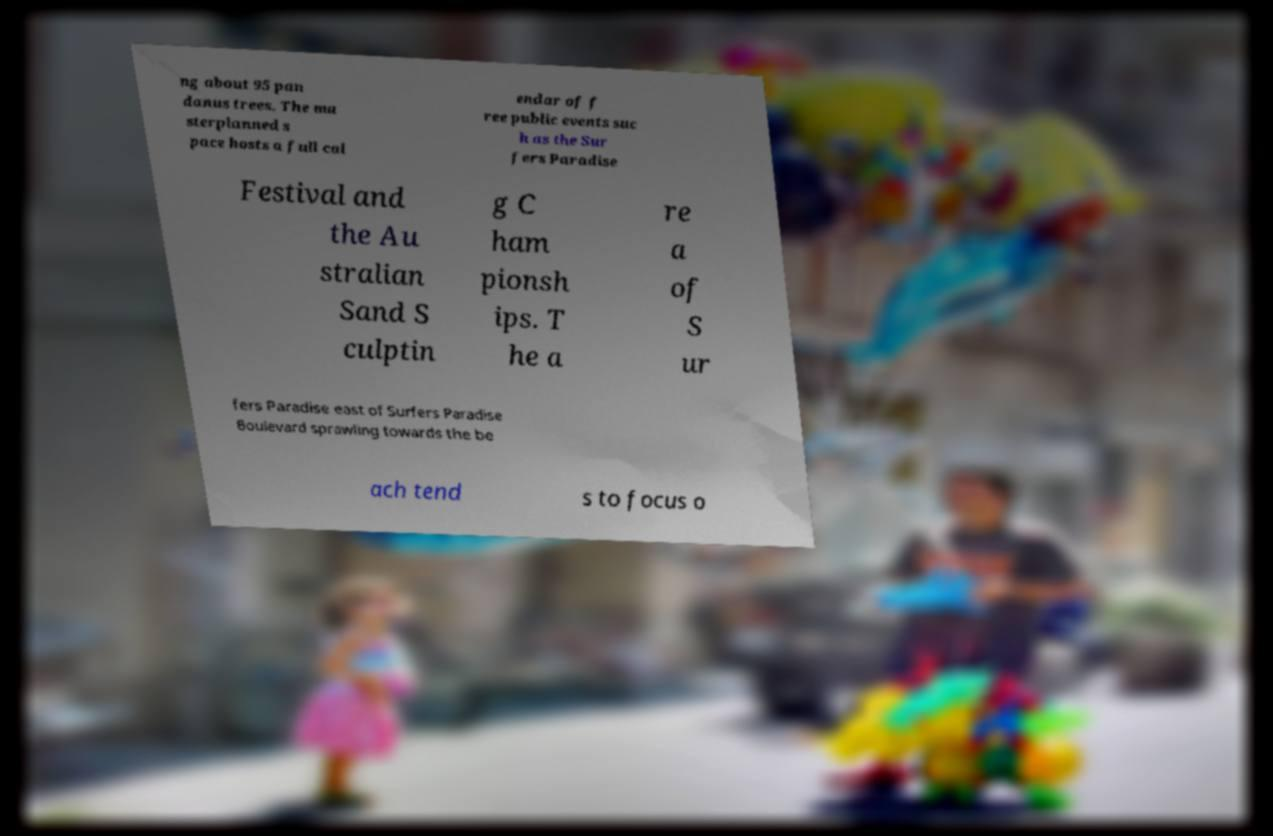Could you assist in decoding the text presented in this image and type it out clearly? ng about 95 pan danus trees. The ma sterplanned s pace hosts a full cal endar of f ree public events suc h as the Sur fers Paradise Festival and the Au stralian Sand S culptin g C ham pionsh ips. T he a re a of S ur fers Paradise east of Surfers Paradise Boulevard sprawling towards the be ach tend s to focus o 